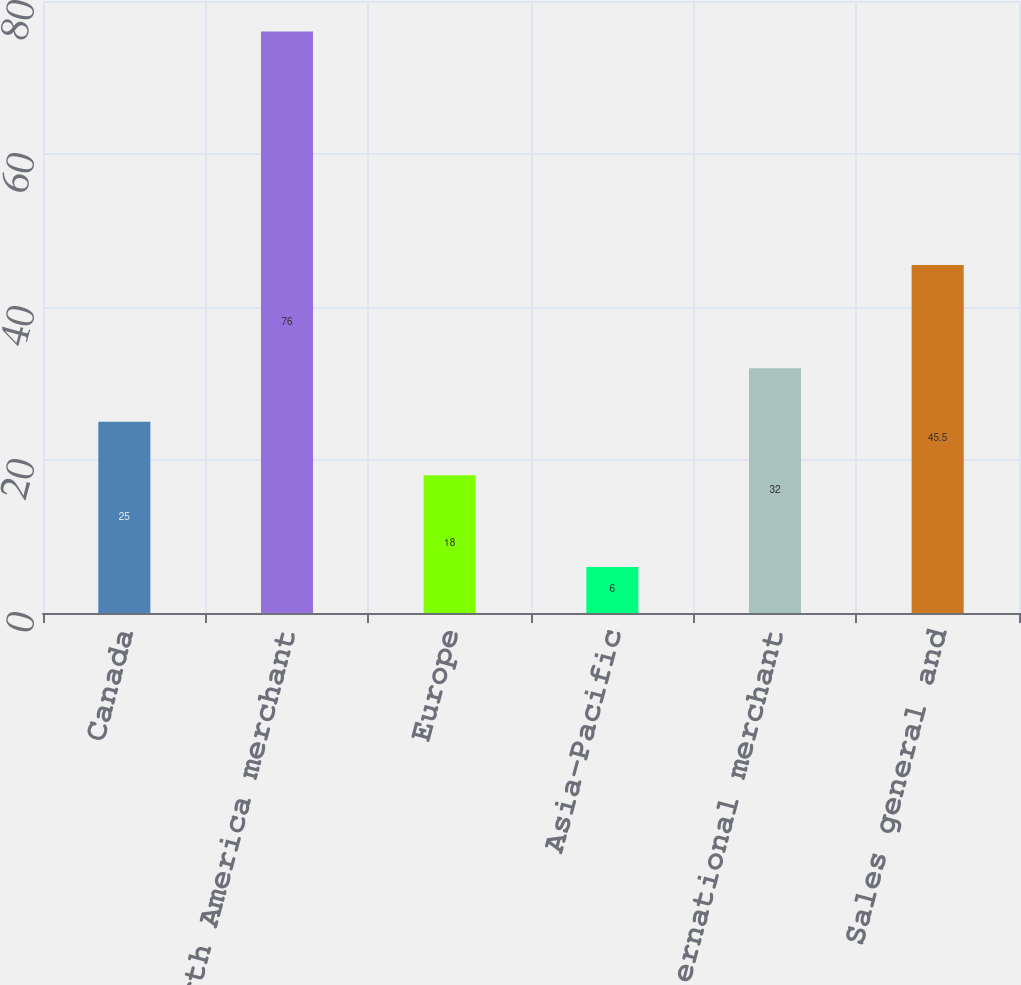Convert chart to OTSL. <chart><loc_0><loc_0><loc_500><loc_500><bar_chart><fcel>Canada<fcel>North America merchant<fcel>Europe<fcel>Asia-Pacific<fcel>International merchant<fcel>Sales general and<nl><fcel>25<fcel>76<fcel>18<fcel>6<fcel>32<fcel>45.5<nl></chart> 